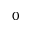<formula> <loc_0><loc_0><loc_500><loc_500>0</formula> 